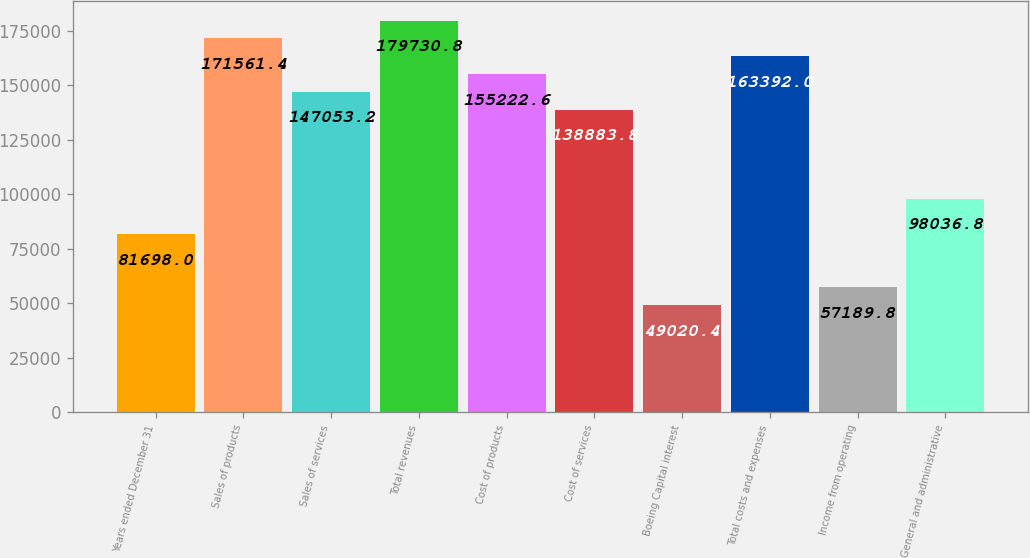<chart> <loc_0><loc_0><loc_500><loc_500><bar_chart><fcel>Years ended December 31<fcel>Sales of products<fcel>Sales of services<fcel>Total revenues<fcel>Cost of products<fcel>Cost of services<fcel>Boeing Capital interest<fcel>Total costs and expenses<fcel>Income from operating<fcel>General and administrative<nl><fcel>81698<fcel>171561<fcel>147053<fcel>179731<fcel>155223<fcel>138884<fcel>49020.4<fcel>163392<fcel>57189.8<fcel>98036.8<nl></chart> 